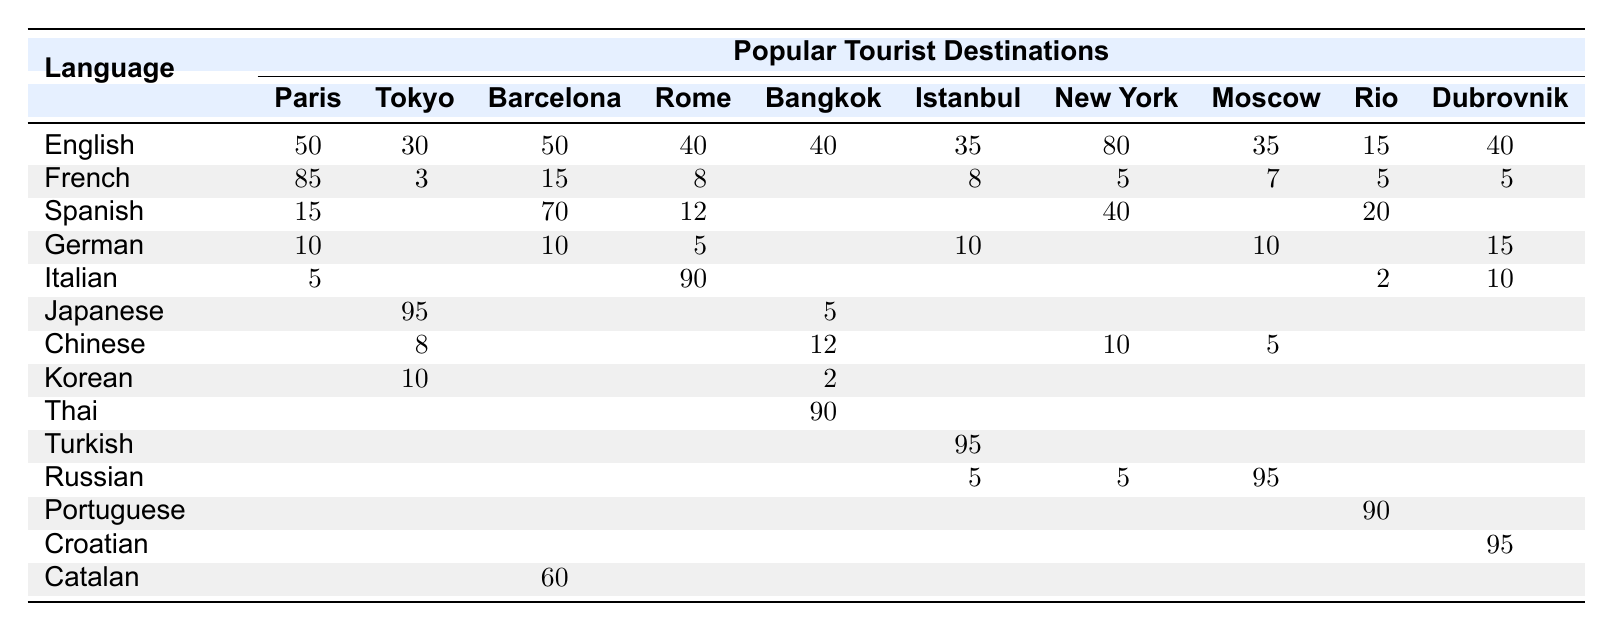What is the most spoken language in Paris? By looking at the table, we can see that French has the highest frequency at 85.
Answer: French How many languages are spoken in Tokyo? In Tokyo, the languages listed are Japanese, English, Korean, Chinese, and French. This makes a total of 5 languages.
Answer: 5 Which destination has the highest percentage of English speakers? In New York City, 80% of locals speak English, which is higher than any other destination listed.
Answer: New York City What is the percentage of speakers of Italian in Rome? The table shows that 90% of locals in Rome speak Italian, which is the highest among the languages listed for that city.
Answer: 90 Are there any local languages spoken in Bangkok other than English? Yes, Thai is spoken by 90% of locals, and there are also Chinese speakers (12%), Japanese (5%), and Korean (2%).
Answer: Yes What is the total percentage of German speakers in Barcelona and Rome? In Barcelona, 10% speak German and in Rome 5% speak German. Adding them together gives us 10 + 5 = 15%.
Answer: 15 Is Spanish commonly spoken in Istanbul? The table shows that there are no Spanish speakers listed in Istanbul. Therefore, the answer is no.
Answer: No Which destination has the fewest speakers of Korean? In Bangkok, there are only 2% of speakers of Korean, which is fewer than any other destination.
Answer: Bangkok What is the difference in the percentage of English speakers between Paris and Moscow? In Paris, 50% speak English, while in Moscow, it’s 35%. The difference is 50 - 35 = 15%.
Answer: 15 What is the average percentage of English speakers across all destinations listed? The percentages of English speakers are: 50, 30, 50, 40, 40, 35, 80, 35, 15, and 40. First, add these values: 50 + 30 + 50 + 40 + 40 + 35 + 80 + 35 + 15 + 40 = 420. Then, divide by the number of destinations (10): 420 / 10 = 42%.
Answer: 42 